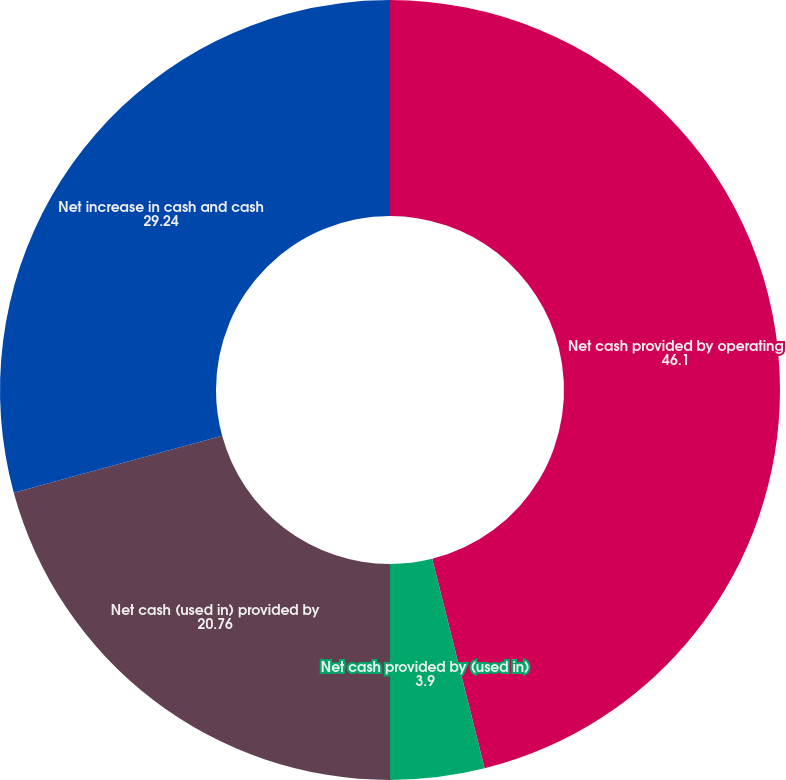<chart> <loc_0><loc_0><loc_500><loc_500><pie_chart><fcel>Net cash provided by operating<fcel>Net cash provided by (used in)<fcel>Net cash (used in) provided by<fcel>Net increase in cash and cash<nl><fcel>46.1%<fcel>3.9%<fcel>20.76%<fcel>29.24%<nl></chart> 